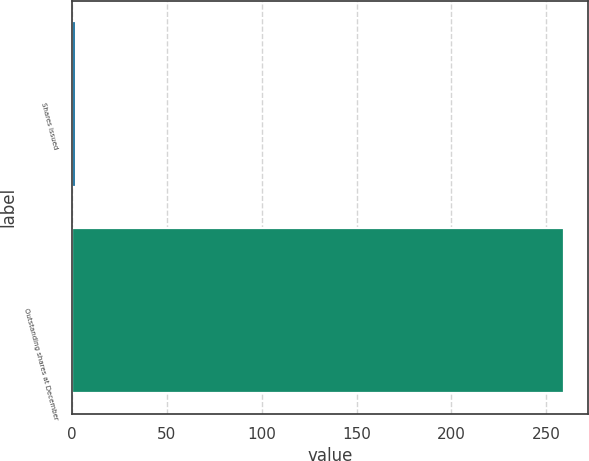Convert chart to OTSL. <chart><loc_0><loc_0><loc_500><loc_500><bar_chart><fcel>Shares issued<fcel>Outstanding shares at December<nl><fcel>2.2<fcel>259.1<nl></chart> 